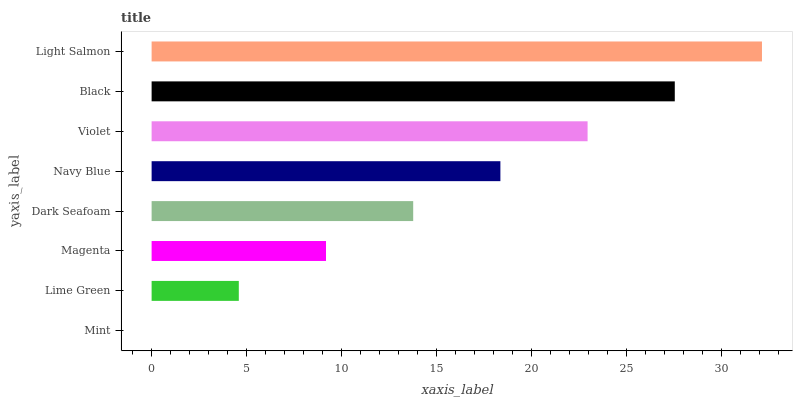Is Mint the minimum?
Answer yes or no. Yes. Is Light Salmon the maximum?
Answer yes or no. Yes. Is Lime Green the minimum?
Answer yes or no. No. Is Lime Green the maximum?
Answer yes or no. No. Is Lime Green greater than Mint?
Answer yes or no. Yes. Is Mint less than Lime Green?
Answer yes or no. Yes. Is Mint greater than Lime Green?
Answer yes or no. No. Is Lime Green less than Mint?
Answer yes or no. No. Is Navy Blue the high median?
Answer yes or no. Yes. Is Dark Seafoam the low median?
Answer yes or no. Yes. Is Violet the high median?
Answer yes or no. No. Is Magenta the low median?
Answer yes or no. No. 